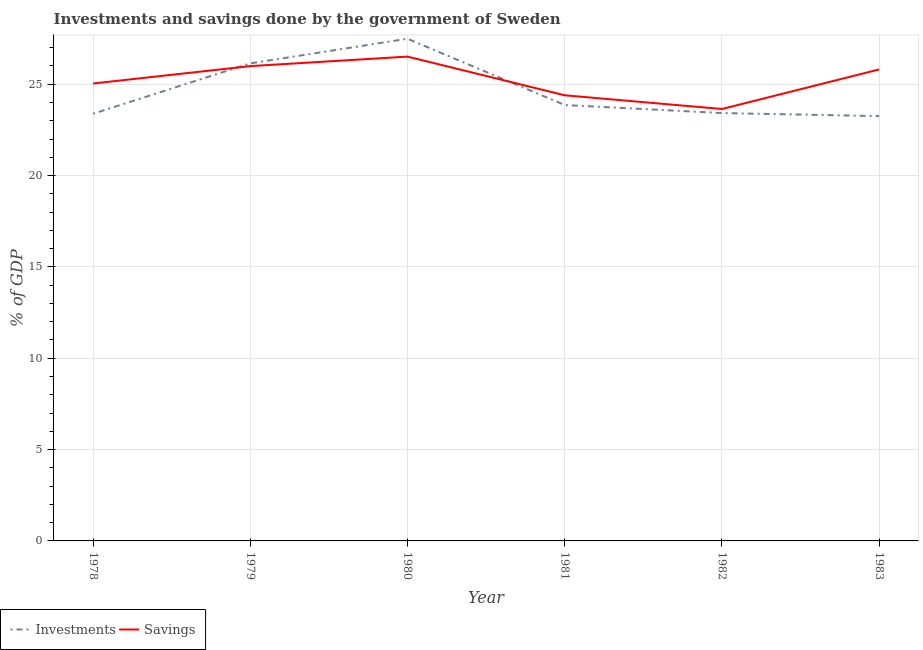How many different coloured lines are there?
Provide a short and direct response. 2. What is the investments of government in 1980?
Your response must be concise. 27.49. Across all years, what is the maximum savings of government?
Ensure brevity in your answer.  26.51. Across all years, what is the minimum savings of government?
Ensure brevity in your answer.  23.65. In which year was the savings of government maximum?
Provide a short and direct response. 1980. In which year was the investments of government minimum?
Keep it short and to the point. 1983. What is the total savings of government in the graph?
Make the answer very short. 151.4. What is the difference between the investments of government in 1978 and that in 1983?
Your response must be concise. 0.13. What is the difference between the investments of government in 1981 and the savings of government in 1982?
Ensure brevity in your answer.  0.22. What is the average investments of government per year?
Provide a succinct answer. 24.59. In the year 1979, what is the difference between the savings of government and investments of government?
Your answer should be very brief. -0.15. What is the ratio of the savings of government in 1981 to that in 1982?
Offer a terse response. 1.03. Is the savings of government in 1979 less than that in 1980?
Keep it short and to the point. Yes. What is the difference between the highest and the second highest investments of government?
Make the answer very short. 1.35. What is the difference between the highest and the lowest investments of government?
Your answer should be very brief. 4.24. Is the sum of the savings of government in 1978 and 1982 greater than the maximum investments of government across all years?
Offer a terse response. Yes. Does the investments of government monotonically increase over the years?
Your response must be concise. No. Is the investments of government strictly less than the savings of government over the years?
Make the answer very short. No. How many years are there in the graph?
Your answer should be very brief. 6. What is the difference between two consecutive major ticks on the Y-axis?
Provide a succinct answer. 5. Does the graph contain any zero values?
Your answer should be compact. No. Where does the legend appear in the graph?
Provide a succinct answer. Bottom left. How many legend labels are there?
Make the answer very short. 2. How are the legend labels stacked?
Your answer should be very brief. Horizontal. What is the title of the graph?
Your answer should be compact. Investments and savings done by the government of Sweden. Does "% of gross capital formation" appear as one of the legend labels in the graph?
Keep it short and to the point. No. What is the label or title of the Y-axis?
Give a very brief answer. % of GDP. What is the % of GDP in Investments in 1978?
Your response must be concise. 23.39. What is the % of GDP of Savings in 1978?
Offer a terse response. 25.04. What is the % of GDP in Investments in 1979?
Keep it short and to the point. 26.14. What is the % of GDP in Savings in 1979?
Provide a succinct answer. 25.99. What is the % of GDP of Investments in 1980?
Offer a very short reply. 27.49. What is the % of GDP in Savings in 1980?
Give a very brief answer. 26.51. What is the % of GDP of Investments in 1981?
Give a very brief answer. 23.86. What is the % of GDP of Savings in 1981?
Make the answer very short. 24.4. What is the % of GDP in Investments in 1982?
Ensure brevity in your answer.  23.42. What is the % of GDP of Savings in 1982?
Keep it short and to the point. 23.65. What is the % of GDP of Investments in 1983?
Give a very brief answer. 23.26. What is the % of GDP of Savings in 1983?
Offer a terse response. 25.81. Across all years, what is the maximum % of GDP of Investments?
Provide a short and direct response. 27.49. Across all years, what is the maximum % of GDP of Savings?
Keep it short and to the point. 26.51. Across all years, what is the minimum % of GDP of Investments?
Provide a short and direct response. 23.26. Across all years, what is the minimum % of GDP of Savings?
Your response must be concise. 23.65. What is the total % of GDP in Investments in the graph?
Your answer should be very brief. 147.56. What is the total % of GDP in Savings in the graph?
Your answer should be very brief. 151.4. What is the difference between the % of GDP in Investments in 1978 and that in 1979?
Offer a very short reply. -2.76. What is the difference between the % of GDP of Savings in 1978 and that in 1979?
Provide a succinct answer. -0.95. What is the difference between the % of GDP of Investments in 1978 and that in 1980?
Offer a terse response. -4.11. What is the difference between the % of GDP of Savings in 1978 and that in 1980?
Provide a succinct answer. -1.47. What is the difference between the % of GDP of Investments in 1978 and that in 1981?
Your response must be concise. -0.48. What is the difference between the % of GDP in Savings in 1978 and that in 1981?
Provide a succinct answer. 0.64. What is the difference between the % of GDP in Investments in 1978 and that in 1982?
Your answer should be very brief. -0.04. What is the difference between the % of GDP in Savings in 1978 and that in 1982?
Give a very brief answer. 1.39. What is the difference between the % of GDP in Investments in 1978 and that in 1983?
Your answer should be compact. 0.13. What is the difference between the % of GDP of Savings in 1978 and that in 1983?
Give a very brief answer. -0.77. What is the difference between the % of GDP in Investments in 1979 and that in 1980?
Provide a succinct answer. -1.35. What is the difference between the % of GDP of Savings in 1979 and that in 1980?
Offer a terse response. -0.52. What is the difference between the % of GDP of Investments in 1979 and that in 1981?
Your response must be concise. 2.28. What is the difference between the % of GDP in Savings in 1979 and that in 1981?
Ensure brevity in your answer.  1.6. What is the difference between the % of GDP of Investments in 1979 and that in 1982?
Keep it short and to the point. 2.72. What is the difference between the % of GDP of Savings in 1979 and that in 1982?
Your answer should be very brief. 2.35. What is the difference between the % of GDP of Investments in 1979 and that in 1983?
Your answer should be compact. 2.89. What is the difference between the % of GDP of Savings in 1979 and that in 1983?
Provide a succinct answer. 0.18. What is the difference between the % of GDP of Investments in 1980 and that in 1981?
Offer a very short reply. 3.63. What is the difference between the % of GDP in Savings in 1980 and that in 1981?
Make the answer very short. 2.12. What is the difference between the % of GDP of Investments in 1980 and that in 1982?
Your answer should be very brief. 4.07. What is the difference between the % of GDP in Savings in 1980 and that in 1982?
Your answer should be very brief. 2.87. What is the difference between the % of GDP of Investments in 1980 and that in 1983?
Give a very brief answer. 4.24. What is the difference between the % of GDP in Savings in 1980 and that in 1983?
Keep it short and to the point. 0.7. What is the difference between the % of GDP of Investments in 1981 and that in 1982?
Keep it short and to the point. 0.44. What is the difference between the % of GDP of Savings in 1981 and that in 1982?
Your answer should be very brief. 0.75. What is the difference between the % of GDP of Investments in 1981 and that in 1983?
Provide a short and direct response. 0.61. What is the difference between the % of GDP in Savings in 1981 and that in 1983?
Your answer should be very brief. -1.42. What is the difference between the % of GDP in Investments in 1982 and that in 1983?
Keep it short and to the point. 0.17. What is the difference between the % of GDP in Savings in 1982 and that in 1983?
Your answer should be compact. -2.17. What is the difference between the % of GDP in Investments in 1978 and the % of GDP in Savings in 1979?
Provide a succinct answer. -2.61. What is the difference between the % of GDP in Investments in 1978 and the % of GDP in Savings in 1980?
Provide a succinct answer. -3.13. What is the difference between the % of GDP of Investments in 1978 and the % of GDP of Savings in 1981?
Give a very brief answer. -1.01. What is the difference between the % of GDP in Investments in 1978 and the % of GDP in Savings in 1982?
Your answer should be compact. -0.26. What is the difference between the % of GDP in Investments in 1978 and the % of GDP in Savings in 1983?
Offer a very short reply. -2.43. What is the difference between the % of GDP in Investments in 1979 and the % of GDP in Savings in 1980?
Keep it short and to the point. -0.37. What is the difference between the % of GDP of Investments in 1979 and the % of GDP of Savings in 1981?
Give a very brief answer. 1.75. What is the difference between the % of GDP of Investments in 1979 and the % of GDP of Savings in 1982?
Your answer should be compact. 2.5. What is the difference between the % of GDP in Investments in 1979 and the % of GDP in Savings in 1983?
Give a very brief answer. 0.33. What is the difference between the % of GDP of Investments in 1980 and the % of GDP of Savings in 1981?
Keep it short and to the point. 3.1. What is the difference between the % of GDP in Investments in 1980 and the % of GDP in Savings in 1982?
Your answer should be very brief. 3.85. What is the difference between the % of GDP of Investments in 1980 and the % of GDP of Savings in 1983?
Your answer should be very brief. 1.68. What is the difference between the % of GDP in Investments in 1981 and the % of GDP in Savings in 1982?
Keep it short and to the point. 0.22. What is the difference between the % of GDP in Investments in 1981 and the % of GDP in Savings in 1983?
Provide a short and direct response. -1.95. What is the difference between the % of GDP in Investments in 1982 and the % of GDP in Savings in 1983?
Give a very brief answer. -2.39. What is the average % of GDP of Investments per year?
Keep it short and to the point. 24.59. What is the average % of GDP in Savings per year?
Your answer should be compact. 25.23. In the year 1978, what is the difference between the % of GDP in Investments and % of GDP in Savings?
Your answer should be very brief. -1.65. In the year 1979, what is the difference between the % of GDP in Investments and % of GDP in Savings?
Offer a terse response. 0.15. In the year 1980, what is the difference between the % of GDP in Investments and % of GDP in Savings?
Provide a short and direct response. 0.98. In the year 1981, what is the difference between the % of GDP in Investments and % of GDP in Savings?
Give a very brief answer. -0.53. In the year 1982, what is the difference between the % of GDP in Investments and % of GDP in Savings?
Your answer should be compact. -0.22. In the year 1983, what is the difference between the % of GDP of Investments and % of GDP of Savings?
Offer a terse response. -2.56. What is the ratio of the % of GDP in Investments in 1978 to that in 1979?
Offer a terse response. 0.89. What is the ratio of the % of GDP in Savings in 1978 to that in 1979?
Offer a very short reply. 0.96. What is the ratio of the % of GDP in Investments in 1978 to that in 1980?
Offer a very short reply. 0.85. What is the ratio of the % of GDP of Savings in 1978 to that in 1980?
Make the answer very short. 0.94. What is the ratio of the % of GDP of Savings in 1978 to that in 1981?
Keep it short and to the point. 1.03. What is the ratio of the % of GDP of Investments in 1978 to that in 1982?
Offer a terse response. 1. What is the ratio of the % of GDP in Savings in 1978 to that in 1982?
Give a very brief answer. 1.06. What is the ratio of the % of GDP in Investments in 1978 to that in 1983?
Give a very brief answer. 1.01. What is the ratio of the % of GDP in Savings in 1978 to that in 1983?
Your answer should be very brief. 0.97. What is the ratio of the % of GDP in Investments in 1979 to that in 1980?
Provide a short and direct response. 0.95. What is the ratio of the % of GDP in Savings in 1979 to that in 1980?
Your answer should be very brief. 0.98. What is the ratio of the % of GDP of Investments in 1979 to that in 1981?
Provide a succinct answer. 1.1. What is the ratio of the % of GDP of Savings in 1979 to that in 1981?
Provide a short and direct response. 1.07. What is the ratio of the % of GDP in Investments in 1979 to that in 1982?
Provide a succinct answer. 1.12. What is the ratio of the % of GDP of Savings in 1979 to that in 1982?
Offer a terse response. 1.1. What is the ratio of the % of GDP of Investments in 1979 to that in 1983?
Give a very brief answer. 1.12. What is the ratio of the % of GDP in Savings in 1979 to that in 1983?
Your answer should be very brief. 1.01. What is the ratio of the % of GDP of Investments in 1980 to that in 1981?
Provide a succinct answer. 1.15. What is the ratio of the % of GDP of Savings in 1980 to that in 1981?
Make the answer very short. 1.09. What is the ratio of the % of GDP in Investments in 1980 to that in 1982?
Offer a very short reply. 1.17. What is the ratio of the % of GDP of Savings in 1980 to that in 1982?
Offer a very short reply. 1.12. What is the ratio of the % of GDP of Investments in 1980 to that in 1983?
Give a very brief answer. 1.18. What is the ratio of the % of GDP in Savings in 1980 to that in 1983?
Provide a succinct answer. 1.03. What is the ratio of the % of GDP of Investments in 1981 to that in 1982?
Your answer should be compact. 1.02. What is the ratio of the % of GDP in Savings in 1981 to that in 1982?
Provide a succinct answer. 1.03. What is the ratio of the % of GDP of Investments in 1981 to that in 1983?
Offer a terse response. 1.03. What is the ratio of the % of GDP of Savings in 1981 to that in 1983?
Keep it short and to the point. 0.95. What is the ratio of the % of GDP in Investments in 1982 to that in 1983?
Provide a succinct answer. 1.01. What is the ratio of the % of GDP of Savings in 1982 to that in 1983?
Provide a short and direct response. 0.92. What is the difference between the highest and the second highest % of GDP in Investments?
Provide a succinct answer. 1.35. What is the difference between the highest and the second highest % of GDP of Savings?
Ensure brevity in your answer.  0.52. What is the difference between the highest and the lowest % of GDP of Investments?
Your answer should be very brief. 4.24. What is the difference between the highest and the lowest % of GDP in Savings?
Your answer should be compact. 2.87. 